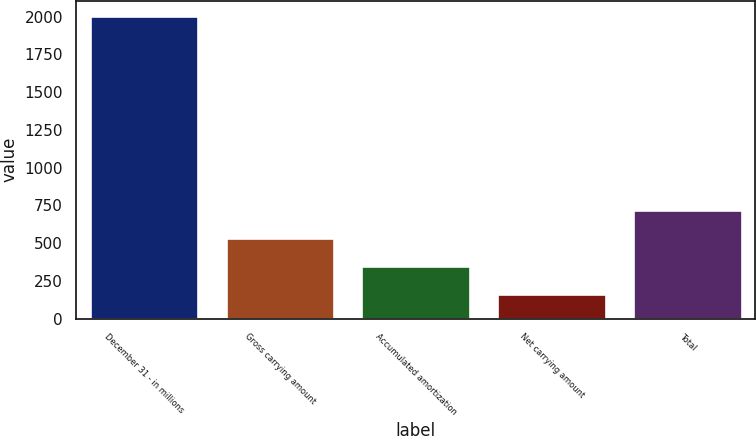<chart> <loc_0><loc_0><loc_500><loc_500><bar_chart><fcel>December 31 - in millions<fcel>Gross carrying amount<fcel>Accumulated amortization<fcel>Net carrying amount<fcel>Total<nl><fcel>2006<fcel>532.4<fcel>348.2<fcel>164<fcel>716.6<nl></chart> 